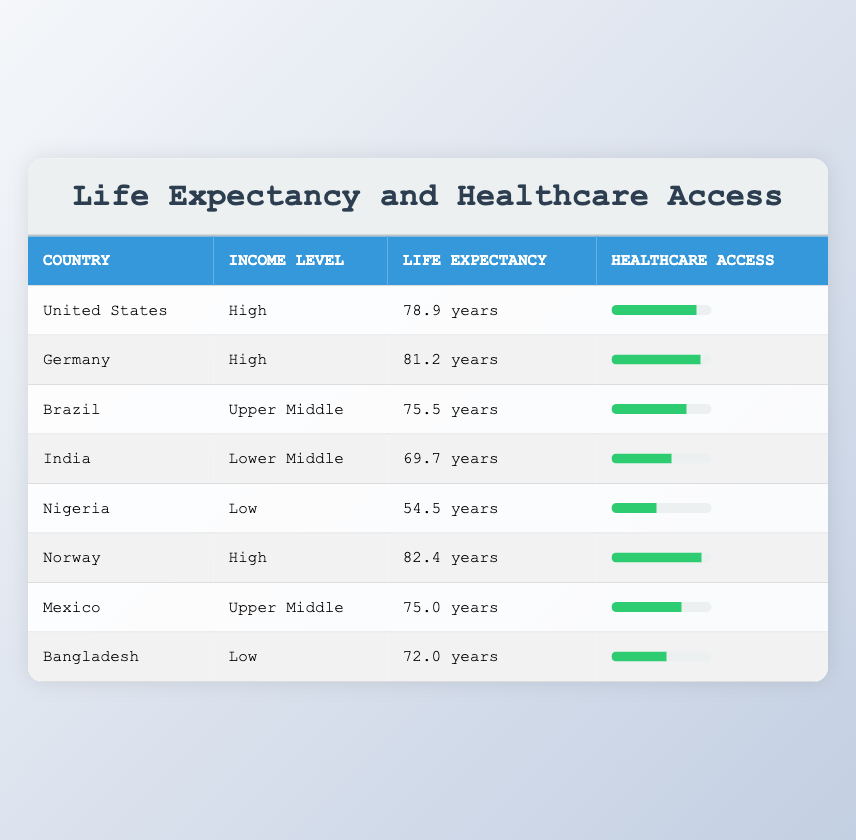What is the average life expectancy for high-income countries in the table? The high-income countries listed are the United States, Germany, and Norway, with respective life expectancies of 78.9, 81.2, and 82.4 years. To find the average, we sum these values: 78.9 + 81.2 + 82.4 = 242.5. Then we divide by 3 (the number of countries): 242.5 / 3 = 80.83.
Answer: 80.83 Which country has the lowest healthcare access score, and what is that score? The country with the lowest healthcare access score is Nigeria, which has a score of 45. This can be directly seen in the table.
Answer: Nigeria; 45 Is the average life expectancy for upper middle-income countries greater than 75 years? The upper middle-income countries in the table are Brazil and Mexico with life expectancies of 75.5 and 75.0 years, respectively. The average is calculated as (75.5 + 75.0) / 2 = 75.25. Since 75.25 is greater than 75, the statement is true.
Answer: Yes What is the difference in life expectancy between the highest and lowest life expectancy recorded in the table? The highest life expectancy is from Norway at 82.4 years, and the lowest is from Nigeria at 54.5 years. To find the difference, we subtract: 82.4 - 54.5 = 27.9 years.
Answer: 27.9 years Does India have a higher healthcare access score than Bangladesh? India has a healthcare access score of 60, while Bangladesh has a score of 55. Since 60 is greater than 55, the statement is true.
Answer: Yes Which country has a higher life expectancy: Brazil or India, and by how much? Brazil has a life expectancy of 75.5 years, and India has 69.7 years. To determine which is higher and by how much, we subtract: 75.5 - 69.7 = 5.8 years. Therefore, Brazil has a higher life expectancy than India by 5.8 years.
Answer: Brazil; 5.8 years What is the average healthcare access score for low-income countries based on this table? The low-income countries are Nigeria (45) and Bangladesh (55). We calculate the average by summing their scores: 45 + 55 = 100. Then, we divide by 2: 100 / 2 = 50.
Answer: 50 Is the average life expectancy for high-income countries higher than that of lower middle-income countries? The average life expectancy for high-income countries is 80.83, while for lower middle-income (India) it is 69.7. Since 80.83 is indeed greater than 69.7, this statement is true.
Answer: Yes 